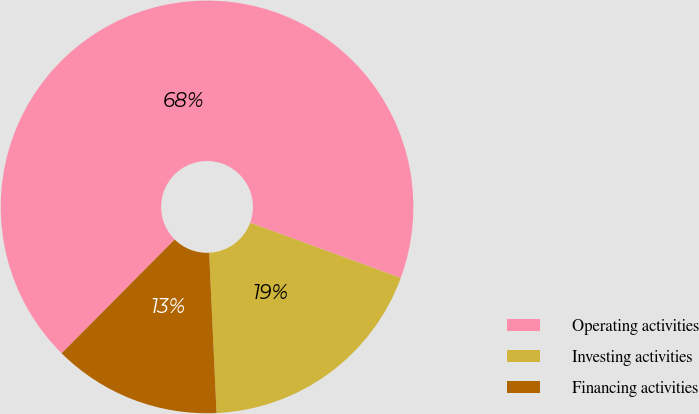Convert chart. <chart><loc_0><loc_0><loc_500><loc_500><pie_chart><fcel>Operating activities<fcel>Investing activities<fcel>Financing activities<nl><fcel>68.15%<fcel>18.67%<fcel>13.18%<nl></chart> 